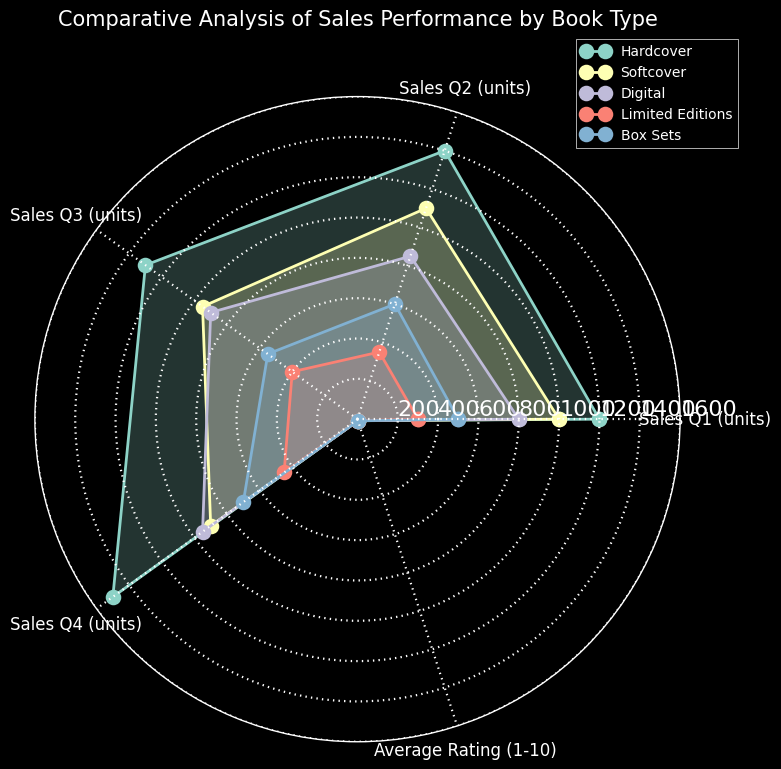Which book type has the highest average rating? The average rating is marked on the radar chart. By comparing the "Average Rating (1-10)" for each book type, we can see that Limited Editions have the highest value.
Answer: Limited Editions Which book type has the lowest Q3 sales? Look at the "Sales Q3 (units)" axis and identify which book type has the shortest length toward the center. Softcover has the shortest length, indicating the lowest sales in Q3.
Answer: Softcover Which book types have an average rating above 8? The "Average Rating (1-10)" can be compared among all book types. Hardcover, Limited Editions, and Box Sets have average ratings above 8.
Answer: Hardcover, Limited Editions, Box Sets By how much do Hardcover Q2 sales exceed Digital Q2 sales? Locate the "Sales Q2 (units)" axis and compare the lengths for Hardcover and Digital. Hardcover sales are 1400 units, and Digital sales are 850 units. The difference is 1400 - 850.
Answer: 550 Which quarter had the highest sales for Softcover books? Check the radar chart's axes for Softcover. The longest radius from the center for Softcover is at "Sales Q2 (units)" with sales of 1100 units.
Answer: Q2 How do Box Sets compare in average rating and Q2 sales? Observe the radar chart for both "Average Rating (1-10)" and "Sales Q2 (units)" of Box Sets. The average rating and Q2 sales for Box Sets are 8.7 and 600 units, respectively.
Answer: 8.7, 600 Rank the book types in descending order of their Q4 sales. Compare the length of the respective "Sales Q4 (units)" axes: Hardcover (1500), Digital (950), Box Sets (700), Limited Editions (450), and Softcover (900).
Answer: Hardcover, Digital, Softcover, Box Sets, Limited Editions Calculate the average sales for Limited Editions across all quarters. The sales for Limited Editions are 300 (Q1), 350 (Q2), 400 (Q3), and 450 (Q4). Add these values and divide by 4: (300 + 350 + 400 + 450) / 4.
Answer: 375 Which book type shows the most consistency across the quarters in terms of sales? Consistency implies minimal variation. Observe the lengths for each book type across all sales quarters. Digital appears the most consistent with values ranging from 800 to 950.
Answer: Digital What can be inferred about the relationship between book type and sales performance over quarters? Observing the radar chart, Hardcover books generally have the highest sales across all quarters, whereas Limited Editions have the lowest but highest rating. Box Sets and Digital show moderate sales and higher ratings compared to Softcover.
Answer: Hardcover performs best in sales, Limited Editions in rating 